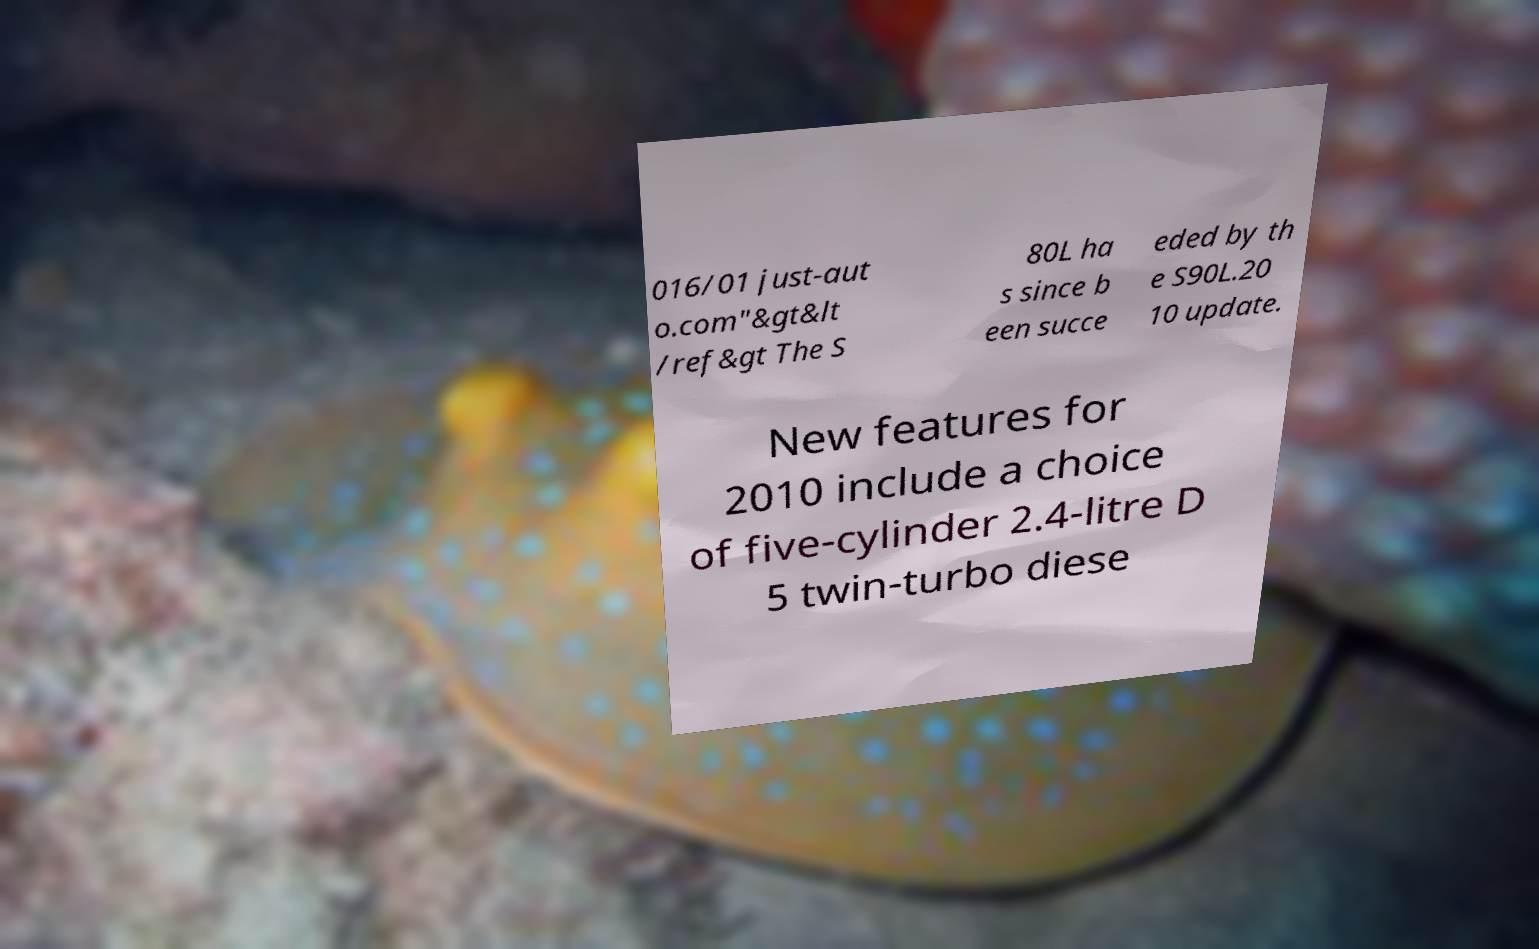For documentation purposes, I need the text within this image transcribed. Could you provide that? 016/01 just-aut o.com"&gt&lt /ref&gt The S 80L ha s since b een succe eded by th e S90L.20 10 update. New features for 2010 include a choice of five-cylinder 2.4-litre D 5 twin-turbo diese 